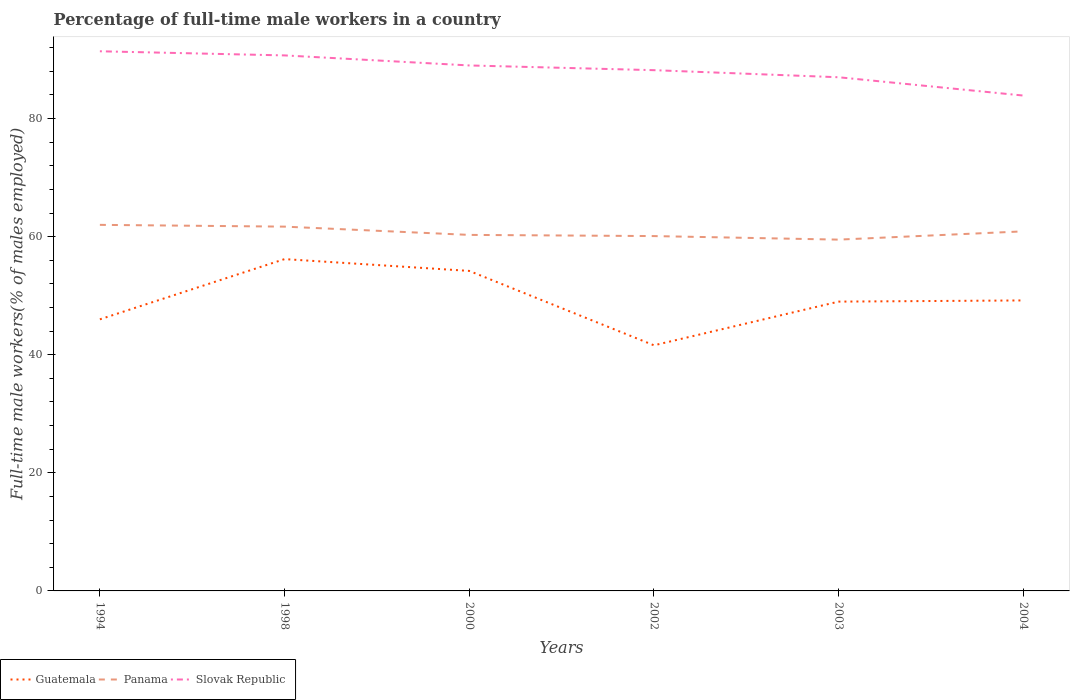Across all years, what is the maximum percentage of full-time male workers in Slovak Republic?
Give a very brief answer. 83.9. What is the total percentage of full-time male workers in Slovak Republic in the graph?
Provide a succinct answer. 0.7. What is the difference between the highest and the lowest percentage of full-time male workers in Guatemala?
Your answer should be very brief. 2. How many years are there in the graph?
Provide a short and direct response. 6. Does the graph contain any zero values?
Your answer should be very brief. No. Where does the legend appear in the graph?
Your response must be concise. Bottom left. How are the legend labels stacked?
Keep it short and to the point. Horizontal. What is the title of the graph?
Your answer should be compact. Percentage of full-time male workers in a country. Does "Germany" appear as one of the legend labels in the graph?
Provide a short and direct response. No. What is the label or title of the Y-axis?
Offer a terse response. Full-time male workers(% of males employed). What is the Full-time male workers(% of males employed) in Slovak Republic in 1994?
Make the answer very short. 91.4. What is the Full-time male workers(% of males employed) of Guatemala in 1998?
Ensure brevity in your answer.  56.2. What is the Full-time male workers(% of males employed) of Panama in 1998?
Your response must be concise. 61.7. What is the Full-time male workers(% of males employed) of Slovak Republic in 1998?
Provide a short and direct response. 90.7. What is the Full-time male workers(% of males employed) in Guatemala in 2000?
Offer a very short reply. 54.2. What is the Full-time male workers(% of males employed) in Panama in 2000?
Provide a succinct answer. 60.3. What is the Full-time male workers(% of males employed) of Slovak Republic in 2000?
Offer a very short reply. 89. What is the Full-time male workers(% of males employed) in Guatemala in 2002?
Give a very brief answer. 41.6. What is the Full-time male workers(% of males employed) in Panama in 2002?
Give a very brief answer. 60.1. What is the Full-time male workers(% of males employed) in Slovak Republic in 2002?
Your answer should be very brief. 88.2. What is the Full-time male workers(% of males employed) in Panama in 2003?
Ensure brevity in your answer.  59.5. What is the Full-time male workers(% of males employed) in Slovak Republic in 2003?
Your answer should be compact. 87. What is the Full-time male workers(% of males employed) in Guatemala in 2004?
Provide a short and direct response. 49.2. What is the Full-time male workers(% of males employed) of Panama in 2004?
Ensure brevity in your answer.  60.9. What is the Full-time male workers(% of males employed) in Slovak Republic in 2004?
Ensure brevity in your answer.  83.9. Across all years, what is the maximum Full-time male workers(% of males employed) in Guatemala?
Offer a very short reply. 56.2. Across all years, what is the maximum Full-time male workers(% of males employed) in Slovak Republic?
Your response must be concise. 91.4. Across all years, what is the minimum Full-time male workers(% of males employed) in Guatemala?
Keep it short and to the point. 41.6. Across all years, what is the minimum Full-time male workers(% of males employed) in Panama?
Offer a terse response. 59.5. Across all years, what is the minimum Full-time male workers(% of males employed) in Slovak Republic?
Your answer should be compact. 83.9. What is the total Full-time male workers(% of males employed) of Guatemala in the graph?
Your answer should be compact. 296.2. What is the total Full-time male workers(% of males employed) of Panama in the graph?
Give a very brief answer. 364.5. What is the total Full-time male workers(% of males employed) in Slovak Republic in the graph?
Your answer should be compact. 530.2. What is the difference between the Full-time male workers(% of males employed) of Guatemala in 1994 and that in 1998?
Keep it short and to the point. -10.2. What is the difference between the Full-time male workers(% of males employed) in Panama in 1994 and that in 1998?
Give a very brief answer. 0.3. What is the difference between the Full-time male workers(% of males employed) in Panama in 1994 and that in 2000?
Your response must be concise. 1.7. What is the difference between the Full-time male workers(% of males employed) of Slovak Republic in 1994 and that in 2000?
Your answer should be compact. 2.4. What is the difference between the Full-time male workers(% of males employed) of Guatemala in 1994 and that in 2003?
Give a very brief answer. -3. What is the difference between the Full-time male workers(% of males employed) of Slovak Republic in 1994 and that in 2003?
Provide a short and direct response. 4.4. What is the difference between the Full-time male workers(% of males employed) in Guatemala in 1994 and that in 2004?
Keep it short and to the point. -3.2. What is the difference between the Full-time male workers(% of males employed) in Slovak Republic in 1994 and that in 2004?
Keep it short and to the point. 7.5. What is the difference between the Full-time male workers(% of males employed) of Guatemala in 1998 and that in 2000?
Your answer should be compact. 2. What is the difference between the Full-time male workers(% of males employed) of Panama in 1998 and that in 2000?
Provide a short and direct response. 1.4. What is the difference between the Full-time male workers(% of males employed) in Slovak Republic in 1998 and that in 2000?
Offer a very short reply. 1.7. What is the difference between the Full-time male workers(% of males employed) in Panama in 1998 and that in 2002?
Provide a succinct answer. 1.6. What is the difference between the Full-time male workers(% of males employed) of Guatemala in 1998 and that in 2003?
Your response must be concise. 7.2. What is the difference between the Full-time male workers(% of males employed) of Guatemala in 1998 and that in 2004?
Your answer should be compact. 7. What is the difference between the Full-time male workers(% of males employed) in Panama in 1998 and that in 2004?
Provide a short and direct response. 0.8. What is the difference between the Full-time male workers(% of males employed) in Slovak Republic in 1998 and that in 2004?
Provide a short and direct response. 6.8. What is the difference between the Full-time male workers(% of males employed) in Panama in 2000 and that in 2002?
Keep it short and to the point. 0.2. What is the difference between the Full-time male workers(% of males employed) in Panama in 2000 and that in 2004?
Keep it short and to the point. -0.6. What is the difference between the Full-time male workers(% of males employed) in Slovak Republic in 2000 and that in 2004?
Provide a succinct answer. 5.1. What is the difference between the Full-time male workers(% of males employed) of Guatemala in 2002 and that in 2003?
Keep it short and to the point. -7.4. What is the difference between the Full-time male workers(% of males employed) of Panama in 2002 and that in 2003?
Give a very brief answer. 0.6. What is the difference between the Full-time male workers(% of males employed) in Slovak Republic in 2003 and that in 2004?
Provide a succinct answer. 3.1. What is the difference between the Full-time male workers(% of males employed) of Guatemala in 1994 and the Full-time male workers(% of males employed) of Panama in 1998?
Provide a short and direct response. -15.7. What is the difference between the Full-time male workers(% of males employed) of Guatemala in 1994 and the Full-time male workers(% of males employed) of Slovak Republic in 1998?
Your answer should be compact. -44.7. What is the difference between the Full-time male workers(% of males employed) of Panama in 1994 and the Full-time male workers(% of males employed) of Slovak Republic in 1998?
Your response must be concise. -28.7. What is the difference between the Full-time male workers(% of males employed) in Guatemala in 1994 and the Full-time male workers(% of males employed) in Panama in 2000?
Ensure brevity in your answer.  -14.3. What is the difference between the Full-time male workers(% of males employed) in Guatemala in 1994 and the Full-time male workers(% of males employed) in Slovak Republic in 2000?
Offer a very short reply. -43. What is the difference between the Full-time male workers(% of males employed) of Guatemala in 1994 and the Full-time male workers(% of males employed) of Panama in 2002?
Ensure brevity in your answer.  -14.1. What is the difference between the Full-time male workers(% of males employed) in Guatemala in 1994 and the Full-time male workers(% of males employed) in Slovak Republic in 2002?
Make the answer very short. -42.2. What is the difference between the Full-time male workers(% of males employed) of Panama in 1994 and the Full-time male workers(% of males employed) of Slovak Republic in 2002?
Your answer should be compact. -26.2. What is the difference between the Full-time male workers(% of males employed) of Guatemala in 1994 and the Full-time male workers(% of males employed) of Slovak Republic in 2003?
Your response must be concise. -41. What is the difference between the Full-time male workers(% of males employed) of Guatemala in 1994 and the Full-time male workers(% of males employed) of Panama in 2004?
Provide a succinct answer. -14.9. What is the difference between the Full-time male workers(% of males employed) of Guatemala in 1994 and the Full-time male workers(% of males employed) of Slovak Republic in 2004?
Provide a succinct answer. -37.9. What is the difference between the Full-time male workers(% of males employed) of Panama in 1994 and the Full-time male workers(% of males employed) of Slovak Republic in 2004?
Offer a terse response. -21.9. What is the difference between the Full-time male workers(% of males employed) in Guatemala in 1998 and the Full-time male workers(% of males employed) in Slovak Republic in 2000?
Your answer should be very brief. -32.8. What is the difference between the Full-time male workers(% of males employed) in Panama in 1998 and the Full-time male workers(% of males employed) in Slovak Republic in 2000?
Your answer should be compact. -27.3. What is the difference between the Full-time male workers(% of males employed) in Guatemala in 1998 and the Full-time male workers(% of males employed) in Panama in 2002?
Your answer should be compact. -3.9. What is the difference between the Full-time male workers(% of males employed) in Guatemala in 1998 and the Full-time male workers(% of males employed) in Slovak Republic in 2002?
Offer a very short reply. -32. What is the difference between the Full-time male workers(% of males employed) in Panama in 1998 and the Full-time male workers(% of males employed) in Slovak Republic in 2002?
Give a very brief answer. -26.5. What is the difference between the Full-time male workers(% of males employed) in Guatemala in 1998 and the Full-time male workers(% of males employed) in Slovak Republic in 2003?
Ensure brevity in your answer.  -30.8. What is the difference between the Full-time male workers(% of males employed) of Panama in 1998 and the Full-time male workers(% of males employed) of Slovak Republic in 2003?
Keep it short and to the point. -25.3. What is the difference between the Full-time male workers(% of males employed) in Guatemala in 1998 and the Full-time male workers(% of males employed) in Panama in 2004?
Provide a succinct answer. -4.7. What is the difference between the Full-time male workers(% of males employed) in Guatemala in 1998 and the Full-time male workers(% of males employed) in Slovak Republic in 2004?
Your answer should be compact. -27.7. What is the difference between the Full-time male workers(% of males employed) in Panama in 1998 and the Full-time male workers(% of males employed) in Slovak Republic in 2004?
Your response must be concise. -22.2. What is the difference between the Full-time male workers(% of males employed) in Guatemala in 2000 and the Full-time male workers(% of males employed) in Slovak Republic in 2002?
Ensure brevity in your answer.  -34. What is the difference between the Full-time male workers(% of males employed) in Panama in 2000 and the Full-time male workers(% of males employed) in Slovak Republic in 2002?
Keep it short and to the point. -27.9. What is the difference between the Full-time male workers(% of males employed) of Guatemala in 2000 and the Full-time male workers(% of males employed) of Slovak Republic in 2003?
Your answer should be compact. -32.8. What is the difference between the Full-time male workers(% of males employed) of Panama in 2000 and the Full-time male workers(% of males employed) of Slovak Republic in 2003?
Ensure brevity in your answer.  -26.7. What is the difference between the Full-time male workers(% of males employed) of Guatemala in 2000 and the Full-time male workers(% of males employed) of Panama in 2004?
Keep it short and to the point. -6.7. What is the difference between the Full-time male workers(% of males employed) in Guatemala in 2000 and the Full-time male workers(% of males employed) in Slovak Republic in 2004?
Offer a very short reply. -29.7. What is the difference between the Full-time male workers(% of males employed) of Panama in 2000 and the Full-time male workers(% of males employed) of Slovak Republic in 2004?
Your response must be concise. -23.6. What is the difference between the Full-time male workers(% of males employed) of Guatemala in 2002 and the Full-time male workers(% of males employed) of Panama in 2003?
Make the answer very short. -17.9. What is the difference between the Full-time male workers(% of males employed) of Guatemala in 2002 and the Full-time male workers(% of males employed) of Slovak Republic in 2003?
Ensure brevity in your answer.  -45.4. What is the difference between the Full-time male workers(% of males employed) of Panama in 2002 and the Full-time male workers(% of males employed) of Slovak Republic in 2003?
Your response must be concise. -26.9. What is the difference between the Full-time male workers(% of males employed) in Guatemala in 2002 and the Full-time male workers(% of males employed) in Panama in 2004?
Your answer should be compact. -19.3. What is the difference between the Full-time male workers(% of males employed) of Guatemala in 2002 and the Full-time male workers(% of males employed) of Slovak Republic in 2004?
Give a very brief answer. -42.3. What is the difference between the Full-time male workers(% of males employed) of Panama in 2002 and the Full-time male workers(% of males employed) of Slovak Republic in 2004?
Offer a terse response. -23.8. What is the difference between the Full-time male workers(% of males employed) of Guatemala in 2003 and the Full-time male workers(% of males employed) of Slovak Republic in 2004?
Ensure brevity in your answer.  -34.9. What is the difference between the Full-time male workers(% of males employed) in Panama in 2003 and the Full-time male workers(% of males employed) in Slovak Republic in 2004?
Ensure brevity in your answer.  -24.4. What is the average Full-time male workers(% of males employed) of Guatemala per year?
Provide a short and direct response. 49.37. What is the average Full-time male workers(% of males employed) in Panama per year?
Provide a succinct answer. 60.75. What is the average Full-time male workers(% of males employed) in Slovak Republic per year?
Provide a succinct answer. 88.37. In the year 1994, what is the difference between the Full-time male workers(% of males employed) in Guatemala and Full-time male workers(% of males employed) in Slovak Republic?
Your response must be concise. -45.4. In the year 1994, what is the difference between the Full-time male workers(% of males employed) in Panama and Full-time male workers(% of males employed) in Slovak Republic?
Give a very brief answer. -29.4. In the year 1998, what is the difference between the Full-time male workers(% of males employed) in Guatemala and Full-time male workers(% of males employed) in Slovak Republic?
Make the answer very short. -34.5. In the year 1998, what is the difference between the Full-time male workers(% of males employed) in Panama and Full-time male workers(% of males employed) in Slovak Republic?
Make the answer very short. -29. In the year 2000, what is the difference between the Full-time male workers(% of males employed) in Guatemala and Full-time male workers(% of males employed) in Slovak Republic?
Make the answer very short. -34.8. In the year 2000, what is the difference between the Full-time male workers(% of males employed) in Panama and Full-time male workers(% of males employed) in Slovak Republic?
Ensure brevity in your answer.  -28.7. In the year 2002, what is the difference between the Full-time male workers(% of males employed) of Guatemala and Full-time male workers(% of males employed) of Panama?
Your answer should be very brief. -18.5. In the year 2002, what is the difference between the Full-time male workers(% of males employed) in Guatemala and Full-time male workers(% of males employed) in Slovak Republic?
Give a very brief answer. -46.6. In the year 2002, what is the difference between the Full-time male workers(% of males employed) in Panama and Full-time male workers(% of males employed) in Slovak Republic?
Your answer should be compact. -28.1. In the year 2003, what is the difference between the Full-time male workers(% of males employed) in Guatemala and Full-time male workers(% of males employed) in Panama?
Make the answer very short. -10.5. In the year 2003, what is the difference between the Full-time male workers(% of males employed) in Guatemala and Full-time male workers(% of males employed) in Slovak Republic?
Your response must be concise. -38. In the year 2003, what is the difference between the Full-time male workers(% of males employed) of Panama and Full-time male workers(% of males employed) of Slovak Republic?
Provide a succinct answer. -27.5. In the year 2004, what is the difference between the Full-time male workers(% of males employed) of Guatemala and Full-time male workers(% of males employed) of Panama?
Your response must be concise. -11.7. In the year 2004, what is the difference between the Full-time male workers(% of males employed) of Guatemala and Full-time male workers(% of males employed) of Slovak Republic?
Offer a terse response. -34.7. In the year 2004, what is the difference between the Full-time male workers(% of males employed) of Panama and Full-time male workers(% of males employed) of Slovak Republic?
Your answer should be very brief. -23. What is the ratio of the Full-time male workers(% of males employed) of Guatemala in 1994 to that in 1998?
Offer a very short reply. 0.82. What is the ratio of the Full-time male workers(% of males employed) in Slovak Republic in 1994 to that in 1998?
Provide a short and direct response. 1.01. What is the ratio of the Full-time male workers(% of males employed) of Guatemala in 1994 to that in 2000?
Provide a succinct answer. 0.85. What is the ratio of the Full-time male workers(% of males employed) of Panama in 1994 to that in 2000?
Keep it short and to the point. 1.03. What is the ratio of the Full-time male workers(% of males employed) in Guatemala in 1994 to that in 2002?
Offer a very short reply. 1.11. What is the ratio of the Full-time male workers(% of males employed) in Panama in 1994 to that in 2002?
Offer a terse response. 1.03. What is the ratio of the Full-time male workers(% of males employed) of Slovak Republic in 1994 to that in 2002?
Your answer should be very brief. 1.04. What is the ratio of the Full-time male workers(% of males employed) of Guatemala in 1994 to that in 2003?
Offer a terse response. 0.94. What is the ratio of the Full-time male workers(% of males employed) in Panama in 1994 to that in 2003?
Your response must be concise. 1.04. What is the ratio of the Full-time male workers(% of males employed) in Slovak Republic in 1994 to that in 2003?
Offer a terse response. 1.05. What is the ratio of the Full-time male workers(% of males employed) of Guatemala in 1994 to that in 2004?
Offer a very short reply. 0.94. What is the ratio of the Full-time male workers(% of males employed) in Panama in 1994 to that in 2004?
Provide a succinct answer. 1.02. What is the ratio of the Full-time male workers(% of males employed) of Slovak Republic in 1994 to that in 2004?
Give a very brief answer. 1.09. What is the ratio of the Full-time male workers(% of males employed) of Guatemala in 1998 to that in 2000?
Ensure brevity in your answer.  1.04. What is the ratio of the Full-time male workers(% of males employed) of Panama in 1998 to that in 2000?
Provide a succinct answer. 1.02. What is the ratio of the Full-time male workers(% of males employed) of Slovak Republic in 1998 to that in 2000?
Offer a terse response. 1.02. What is the ratio of the Full-time male workers(% of males employed) in Guatemala in 1998 to that in 2002?
Keep it short and to the point. 1.35. What is the ratio of the Full-time male workers(% of males employed) in Panama in 1998 to that in 2002?
Keep it short and to the point. 1.03. What is the ratio of the Full-time male workers(% of males employed) in Slovak Republic in 1998 to that in 2002?
Provide a succinct answer. 1.03. What is the ratio of the Full-time male workers(% of males employed) of Guatemala in 1998 to that in 2003?
Offer a terse response. 1.15. What is the ratio of the Full-time male workers(% of males employed) in Panama in 1998 to that in 2003?
Ensure brevity in your answer.  1.04. What is the ratio of the Full-time male workers(% of males employed) in Slovak Republic in 1998 to that in 2003?
Your answer should be very brief. 1.04. What is the ratio of the Full-time male workers(% of males employed) in Guatemala in 1998 to that in 2004?
Offer a very short reply. 1.14. What is the ratio of the Full-time male workers(% of males employed) in Panama in 1998 to that in 2004?
Provide a short and direct response. 1.01. What is the ratio of the Full-time male workers(% of males employed) in Slovak Republic in 1998 to that in 2004?
Ensure brevity in your answer.  1.08. What is the ratio of the Full-time male workers(% of males employed) of Guatemala in 2000 to that in 2002?
Give a very brief answer. 1.3. What is the ratio of the Full-time male workers(% of males employed) in Panama in 2000 to that in 2002?
Ensure brevity in your answer.  1. What is the ratio of the Full-time male workers(% of males employed) in Slovak Republic in 2000 to that in 2002?
Give a very brief answer. 1.01. What is the ratio of the Full-time male workers(% of males employed) of Guatemala in 2000 to that in 2003?
Provide a succinct answer. 1.11. What is the ratio of the Full-time male workers(% of males employed) in Panama in 2000 to that in 2003?
Offer a terse response. 1.01. What is the ratio of the Full-time male workers(% of males employed) of Slovak Republic in 2000 to that in 2003?
Offer a terse response. 1.02. What is the ratio of the Full-time male workers(% of males employed) of Guatemala in 2000 to that in 2004?
Keep it short and to the point. 1.1. What is the ratio of the Full-time male workers(% of males employed) in Panama in 2000 to that in 2004?
Your answer should be very brief. 0.99. What is the ratio of the Full-time male workers(% of males employed) of Slovak Republic in 2000 to that in 2004?
Offer a terse response. 1.06. What is the ratio of the Full-time male workers(% of males employed) in Guatemala in 2002 to that in 2003?
Provide a short and direct response. 0.85. What is the ratio of the Full-time male workers(% of males employed) of Slovak Republic in 2002 to that in 2003?
Give a very brief answer. 1.01. What is the ratio of the Full-time male workers(% of males employed) of Guatemala in 2002 to that in 2004?
Keep it short and to the point. 0.85. What is the ratio of the Full-time male workers(% of males employed) of Panama in 2002 to that in 2004?
Your response must be concise. 0.99. What is the ratio of the Full-time male workers(% of males employed) in Slovak Republic in 2002 to that in 2004?
Make the answer very short. 1.05. What is the ratio of the Full-time male workers(% of males employed) in Slovak Republic in 2003 to that in 2004?
Provide a short and direct response. 1.04. What is the difference between the highest and the second highest Full-time male workers(% of males employed) in Guatemala?
Provide a succinct answer. 2. What is the difference between the highest and the second highest Full-time male workers(% of males employed) of Panama?
Ensure brevity in your answer.  0.3. What is the difference between the highest and the second highest Full-time male workers(% of males employed) in Slovak Republic?
Your response must be concise. 0.7. What is the difference between the highest and the lowest Full-time male workers(% of males employed) of Panama?
Give a very brief answer. 2.5. 